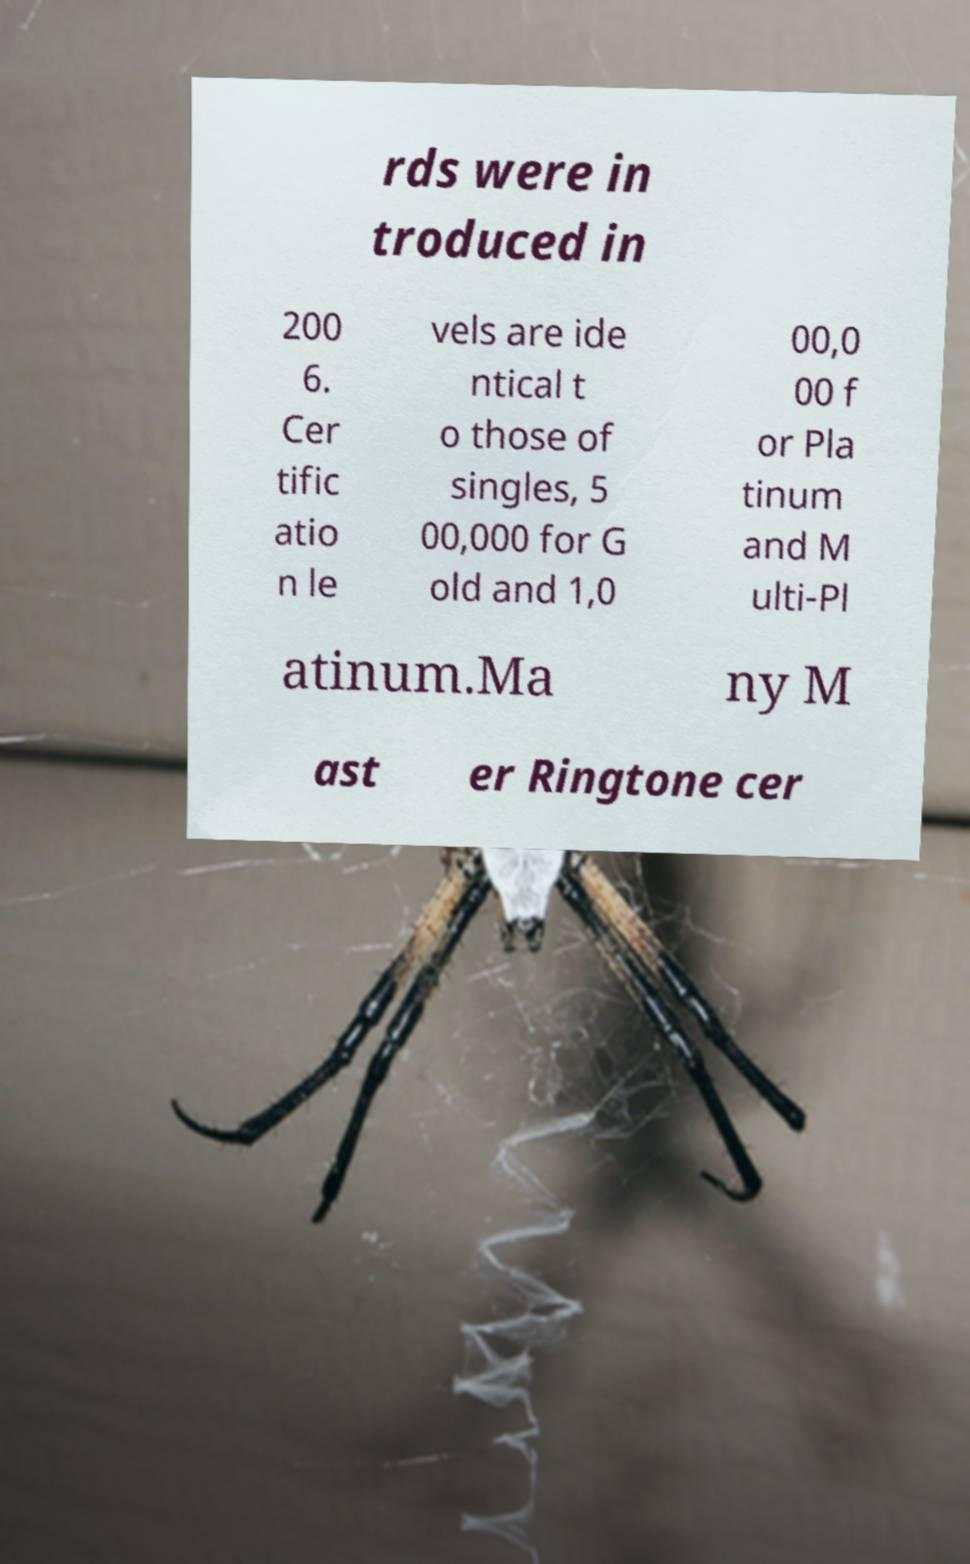I need the written content from this picture converted into text. Can you do that? rds were in troduced in 200 6. Cer tific atio n le vels are ide ntical t o those of singles, 5 00,000 for G old and 1,0 00,0 00 f or Pla tinum and M ulti-Pl atinum.Ma ny M ast er Ringtone cer 